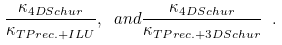Convert formula to latex. <formula><loc_0><loc_0><loc_500><loc_500>\frac { \kappa _ { 4 D S c h u r } } { \kappa _ { T P r e c . + I L U } } , \ a n d \frac { \kappa _ { 4 D S c h u r } } { \kappa _ { T P r e c . + 3 D S c h u r } } \ .</formula> 